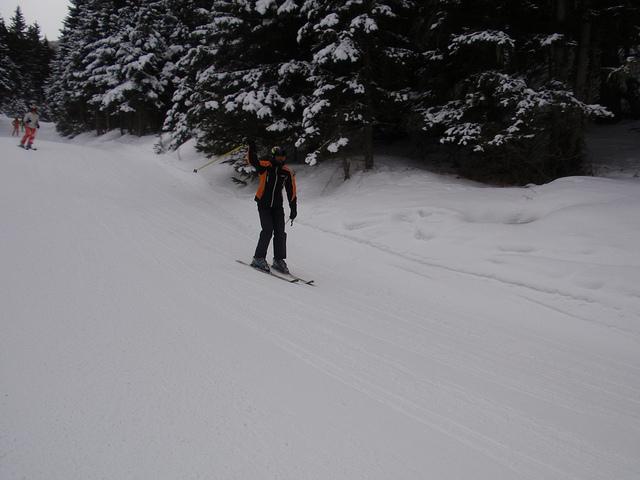Is this person climbing the hill?
Write a very short answer. No. Is the man traveling at a fast speed?
Give a very brief answer. No. Is the skier in motion?
Write a very short answer. Yes. What are the people doing?
Write a very short answer. Skiing. Is the man in a straight up position?
Give a very brief answer. Yes. What kind of skiing is this person doing?
Keep it brief. Downhill. What color is the snow?
Short answer required. White. How many orange flags are there?
Be succinct. 0. 